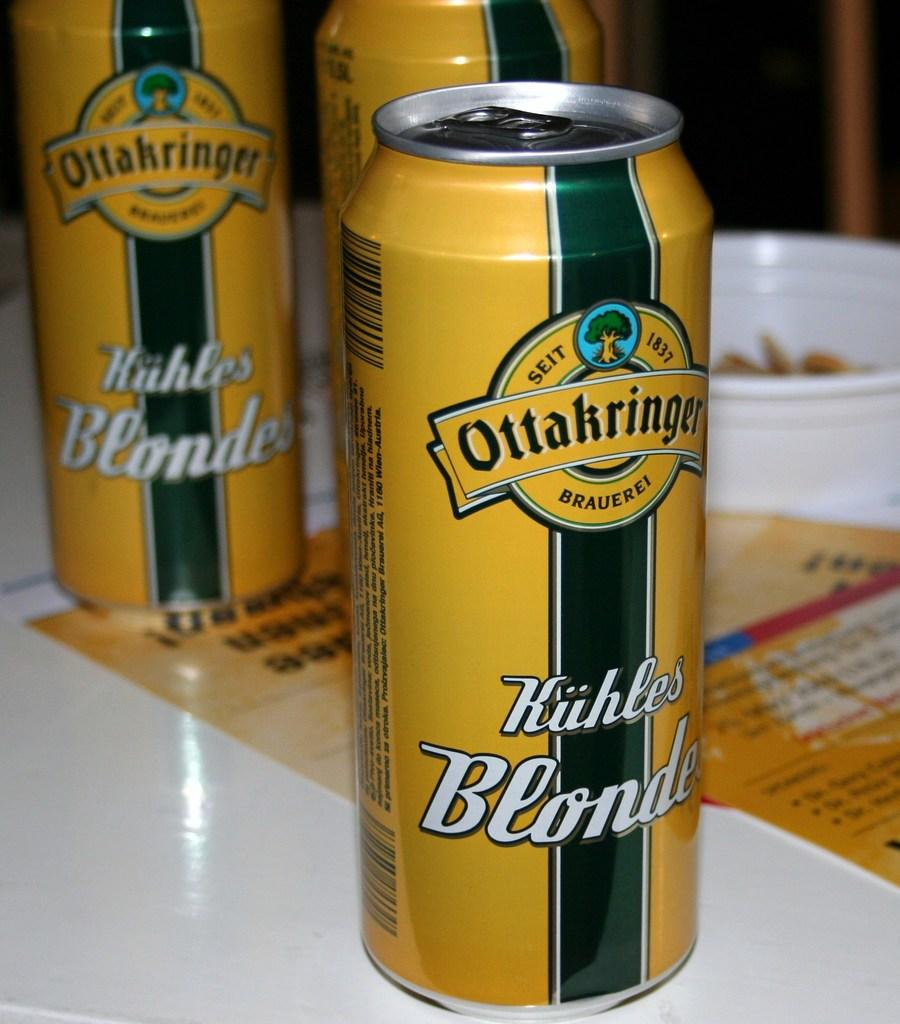<image>
Relay a brief, clear account of the picture shown. Three yellow cans of Ottakringer Kuhles Blonde, one in the foreground, two in the back. 